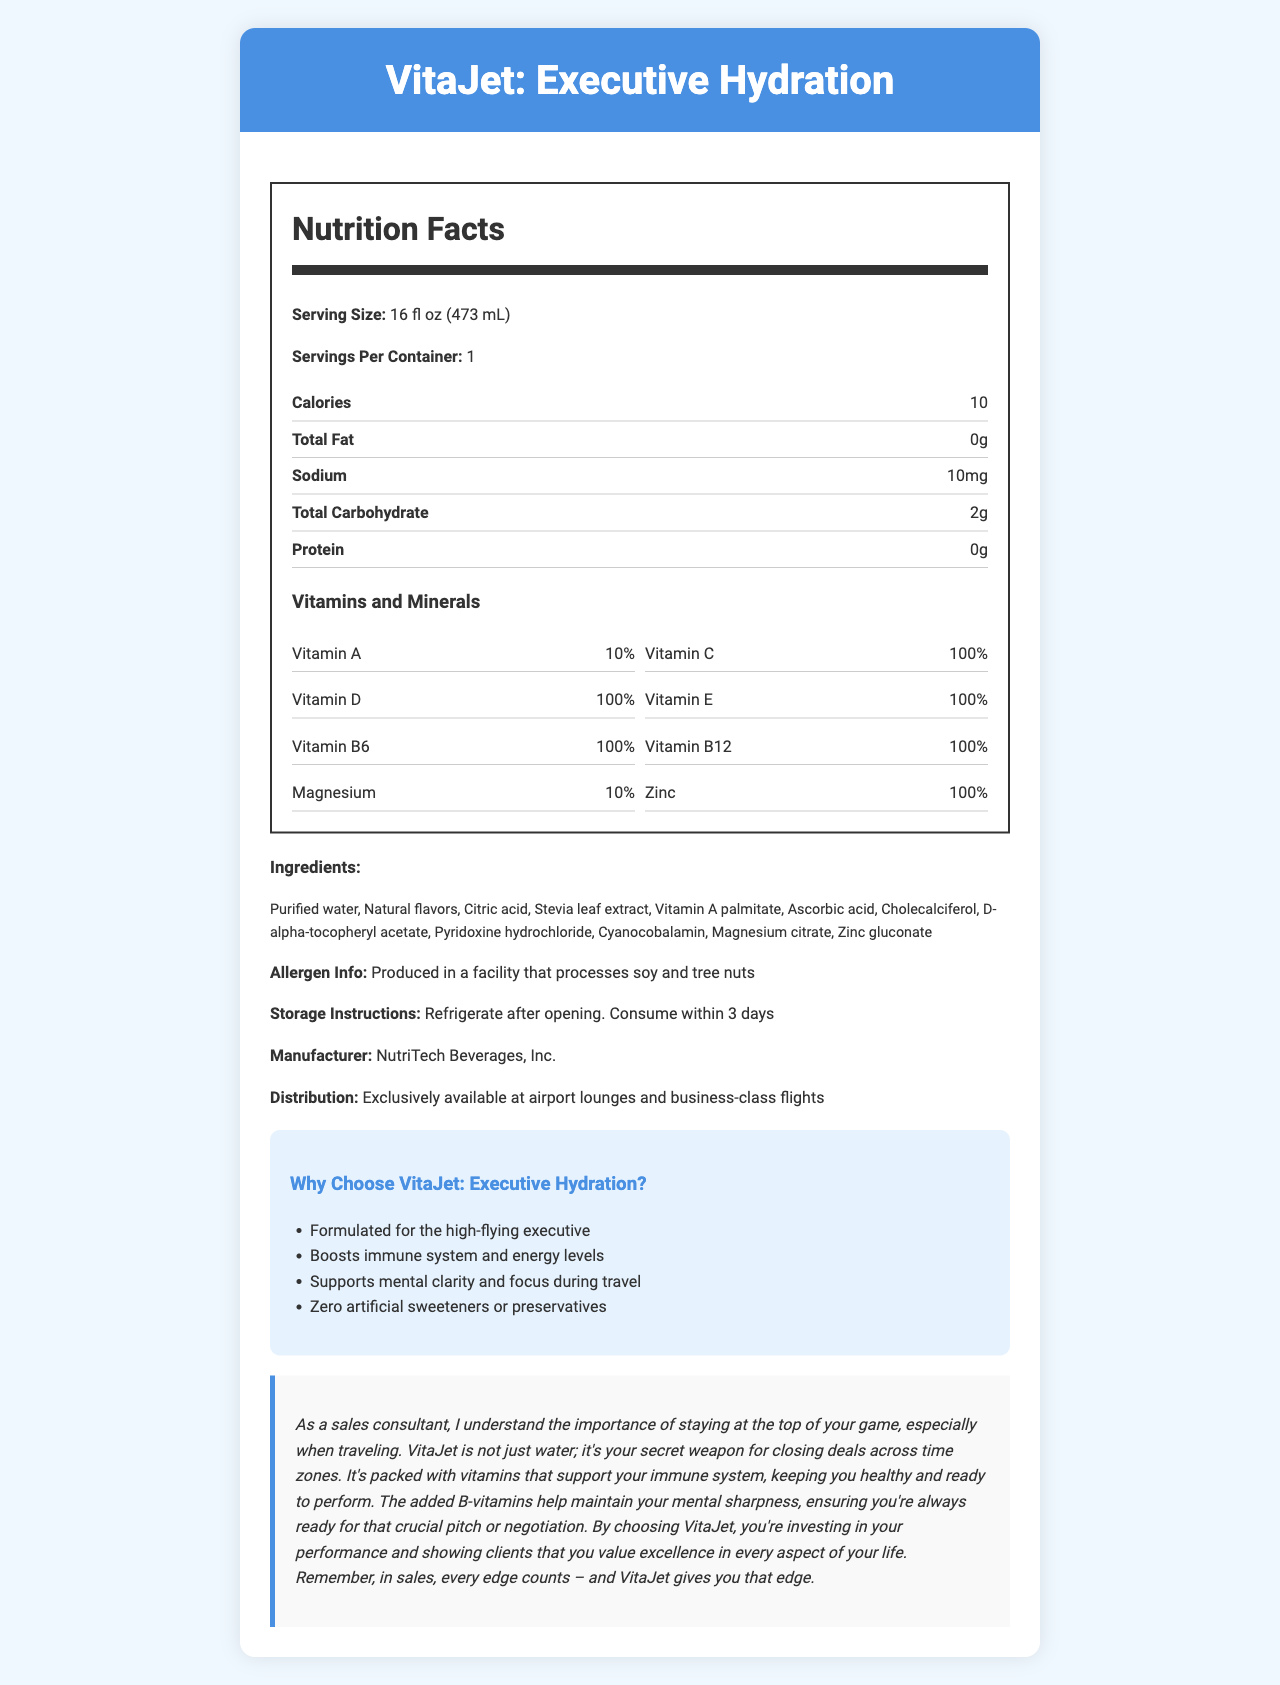what is the serving size? The document indicates that the serving size is 16 fl oz (473 mL).
Answer: 16 fl oz (473 mL) what is the calorie count per serving? The calorie count is listed as 10 calories per serving in the document.
Answer: 10 calories how much sodium is in one serving? The nutrition label specifies that there are 10 mg of sodium per serving.
Answer: 10 mg what percentage of daily value is provided by Vitamin C? The document states that Vitamin C provides 100% of the daily value per serving.
Answer: 100% name two vitamins that are present at 100% of the daily value. Both Vitamin D and Vitamin E are indicated to provide 100% of the daily value per serving.
Answer: Vitamin D and Vitamin E which vitamin does not provide 100% of the daily value? A. Vitamin A B. Vitamin C C. Vitamin B12 The document shows that Vitamin A provides 10% of the daily value, whereas the others provide 100%.
Answer: A. Vitamin A what are the storage instructions? The document states the storage instructions clearly.
Answer: Refrigerate after opening. Consume within 3 days. is the product free from artificial sweeteners? The document’s marketing claims specifically mention "Zero artificial sweeteners or preservatives."
Answer: Yes which of the following ingredients is not listed in the document? i. Magnesium citrate ii. Stevia leaf extract iii. High fructose corn syrup The list of ingredients does not include high fructose corn syrup.
Answer: iii. High fructose corn syrup does the product contain any protein? The document indicates that the protein content is 0g.
Answer: No what are some benefits highlighted in the sales pitch? The sales pitch mentions these specific benefits.
Answer: Boosts immune system, Supports mental clarity, Helps maintain mental sharpness what type of traveler is the product targeted at? The product is described as being "formulated for the high-flying executive," indicating it’s targeting business travelers.
Answer: Health-conscious business travelers describe the main idea of the document. The document describes the nutritional facts, ingredients, storage instructions, and marketing claims for VitaJet: Executive Hydration, emphasizing its benefits for health-conscious business travelers.
Answer: VitaJet: Executive Hydration is a vitamin-fortified bottled water designed for business travelers. It provides hydration along with essential vitamins and minerals, supports immunity, mental clarity, and contains no artificial sweeteners or preservatives. what is the distribution channel for the product? The document explicitly mentions this in the distribution section.
Answer: Exclusively available at airport lounges and business-class flights what is the full name of the manufacturer? The manufacturer is named in the document.
Answer: NutriTech Beverages, Inc. which vitamin is present in the lowest amount? Vitamin B12 is listed as 6 mcg, which is the smallest unit by amount.
Answer: Vitamin B12 which vitamin is indicated to help with mental clarity and focus? A. Vitamin B6 B. Vitamin C C. Vitamin A The marketing claims mention that the product supports mental clarity, and B-vitamins are often associated with brain function.
Answer: A. Vitamin B6 is the product suitable for people with soy allergies? Although the product itself does not list soy as an ingredient, it is produced in a facility that processes soy, so it could potentially cause issues for someone with a severe allergy.
Answer: Not enough information how much Vitamin D is in one serving? The nutrition facts list 400 IU for Vitamin D.
Answer: 400 IU what is included in the allergen information? The document states this information explicitly.
Answer: Produced in a facility that processes soy and tree nuts 